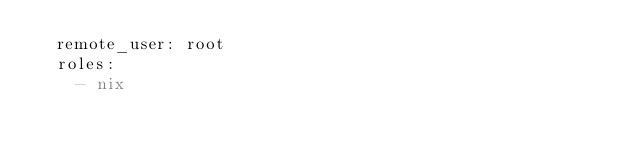Convert code to text. <code><loc_0><loc_0><loc_500><loc_500><_YAML_>  remote_user: root
  roles:
    - nix
</code> 